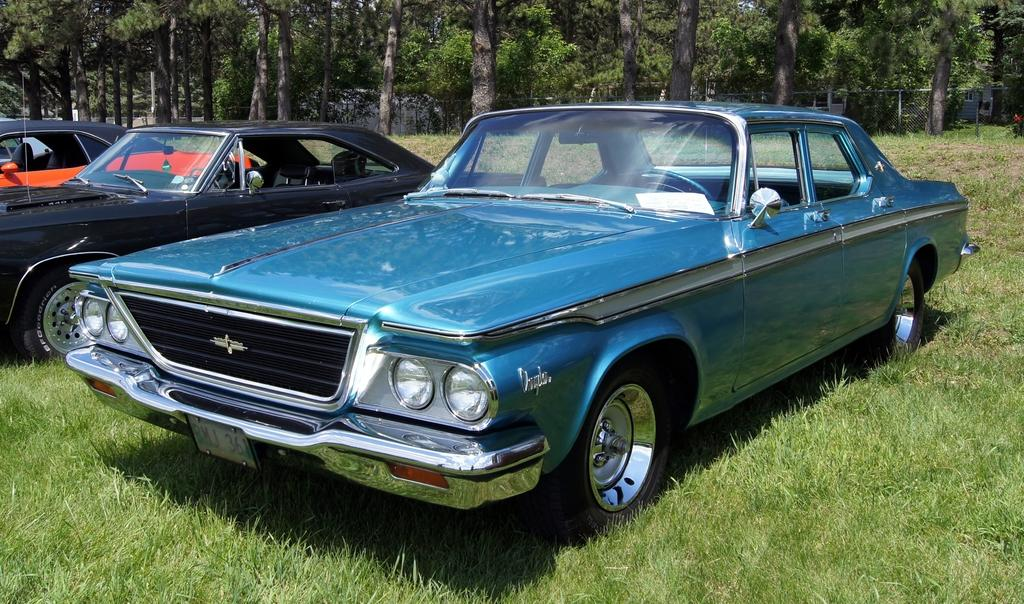What is the main subject in the center of the image? There are vehicles in the center of the image. What can be seen in the background of the image? There are trees, grass, and a compound wall visible in the background of the image. Are there any other objects visible in the background? Yes, there are other objects visible in the background of the image. How many zebras are grazing on the grass in the image? There are no zebras present in the image; it features vehicles and a background with trees, grass, and a compound wall. What type of cloth is draped over the vehicles in the image? There is no cloth draped over the vehicles in the image; it only shows vehicles and the background. 